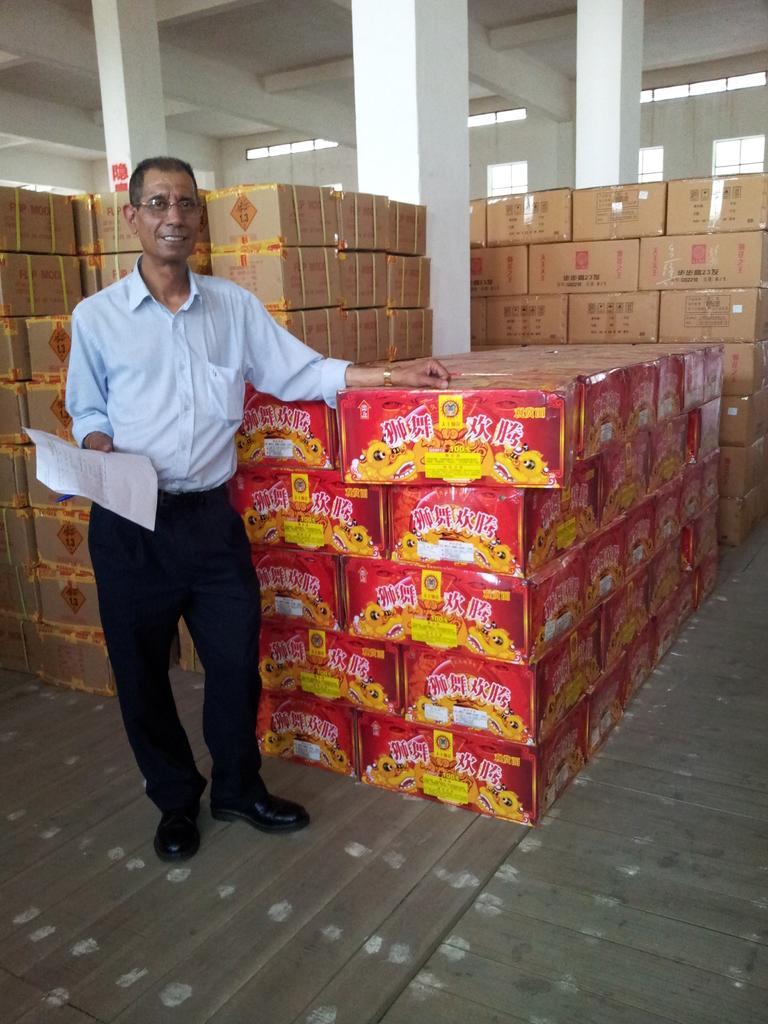Could you give a brief overview of what you see in this image? In this image we can see a person standing on the floor and holding a paper in one of his hands. In the background we can see cardboard cartons arranged in the rows and pillars. 